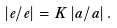<formula> <loc_0><loc_0><loc_500><loc_500>\left | \dot { e } / e \right | = K \left | \dot { a } / a \right | .</formula> 